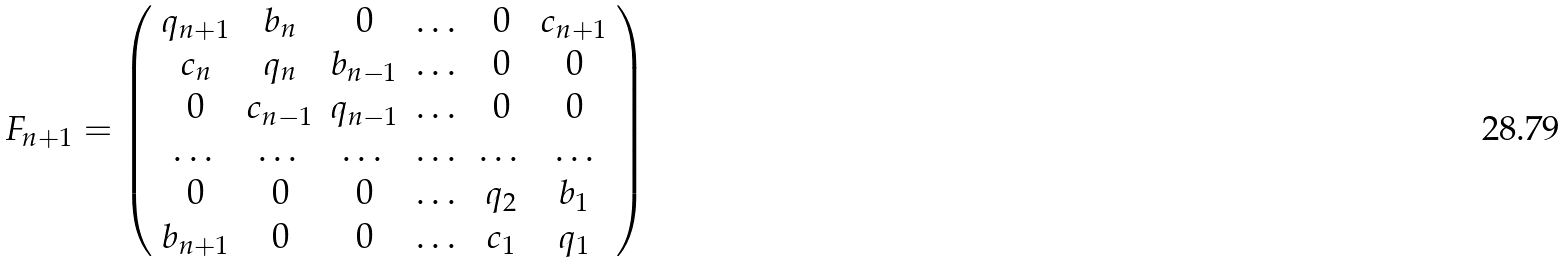Convert formula to latex. <formula><loc_0><loc_0><loc_500><loc_500>F _ { n + 1 } = \left ( \begin{array} { c c c c c c } q _ { n + 1 } & b _ { n } & 0 & \dots & 0 & c _ { n + 1 } \\ c _ { n } & q _ { n } & b _ { n - 1 } & \dots & 0 & 0 \\ 0 & c _ { n - 1 } & q _ { n - 1 } & \dots & 0 & 0 \\ \dots & \dots & \dots & \dots & \dots & \dots \\ 0 & 0 & 0 & \dots & q _ { 2 } & b _ { 1 } \\ b _ { n + 1 } & 0 & 0 & \dots & c _ { 1 } & q _ { 1 } \end{array} \right )</formula> 